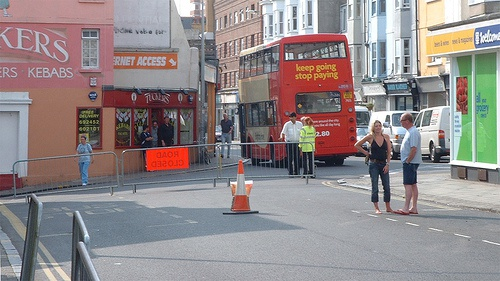Describe the objects in this image and their specific colors. I can see bus in darkgray, brown, and gray tones, people in darkgray and gray tones, car in darkgray, lightgray, gray, and black tones, people in darkgray, black, and gray tones, and truck in darkgray, lightgray, gray, and black tones in this image. 